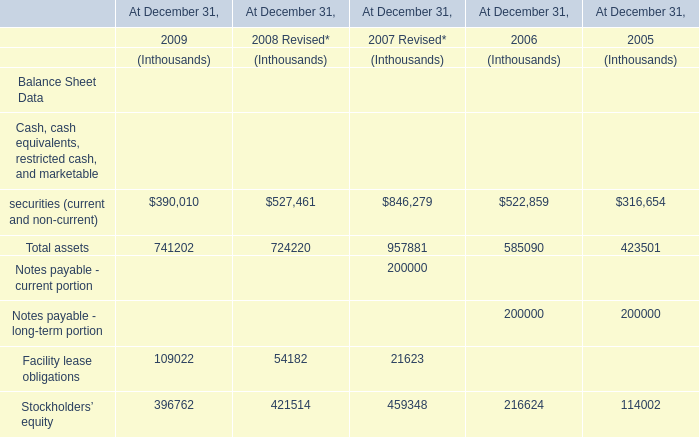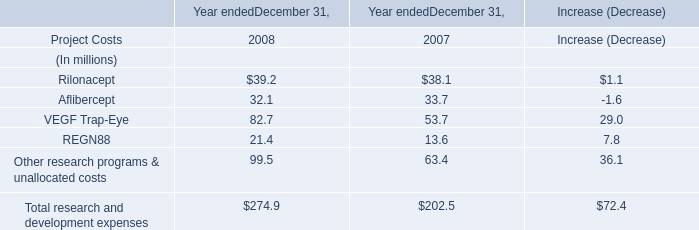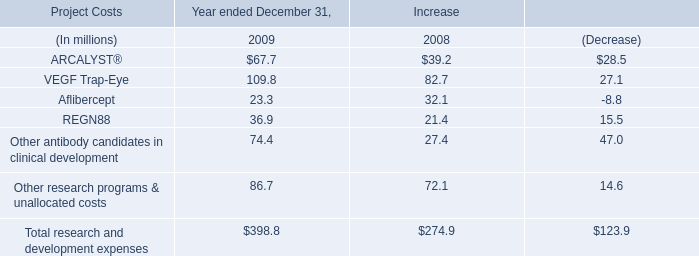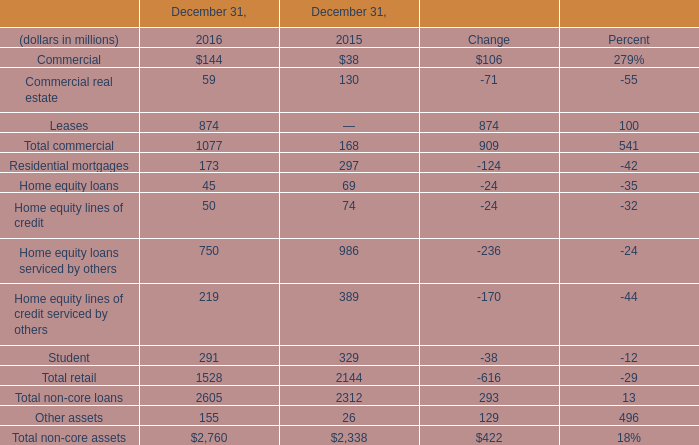What was the total amount of the Facility lease obligations in the years where Total assets greater than 700000? (in thousand) 
Computations: ((109022 + 54182) + 21623)
Answer: 184827.0. 